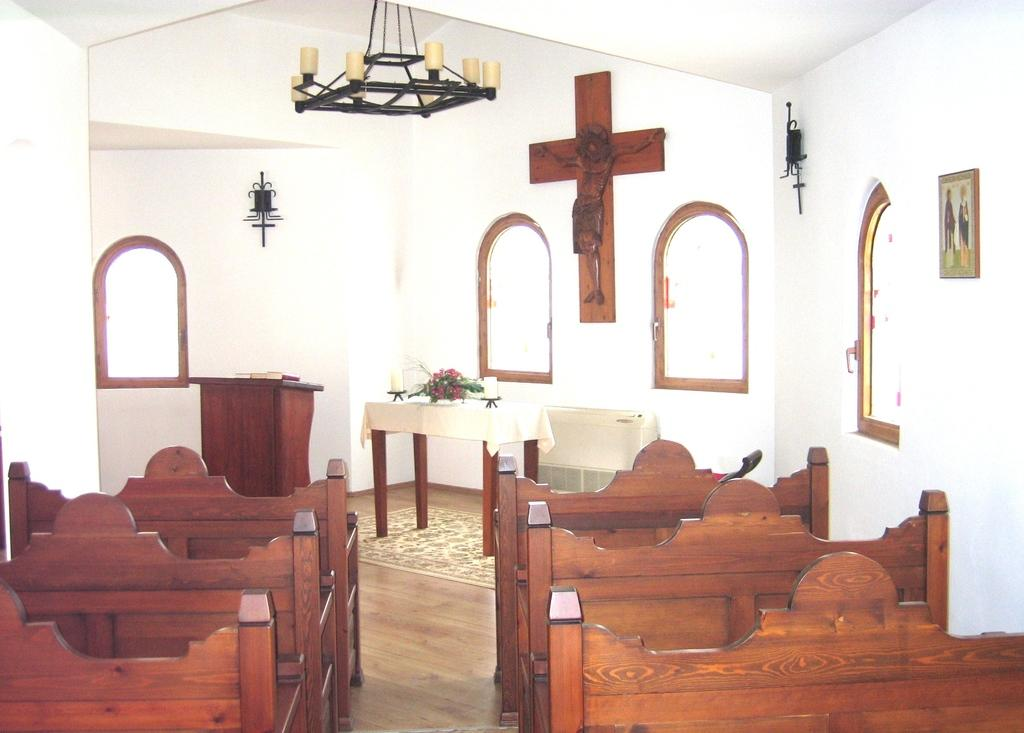What type of seating is visible in the image? There are benches in the image. What can be found on a table in the image? There are objects on a table in the image. What architectural feature is present in the image? There is a wall in the image. What type of artwork is depicted in the image? There is a statue in the image. What type of decorative item is present in the image? There is a frame in the image. What allows natural light to enter the space in the image? There are windows in the image. What type of owl can be seen perched on the statue in the image? There is no owl present in the image; it only features a statue and other objects mentioned in the facts. How does the temper of the person sitting on the bench compare to the person standing near the table? There is no information provided about the temper of any individuals in the image, so we cannot make a comparison. 